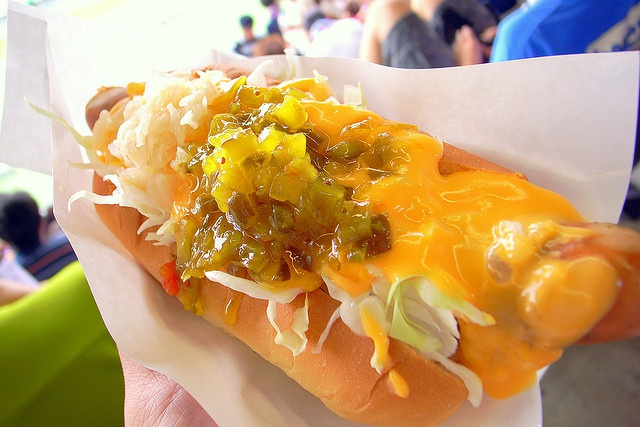Describe the objects in this image and their specific colors. I can see hot dog in white, orange, red, and tan tones, people in white, darkblue, lightblue, and blue tones, people in white, gray, ivory, darkgray, and tan tones, people in white, black, navy, gray, and purple tones, and people in white, lightpink, pink, and salmon tones in this image. 